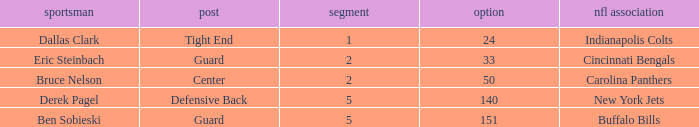What was the latest round that Derek Pagel was selected with a pick higher than 50? 5.0. 